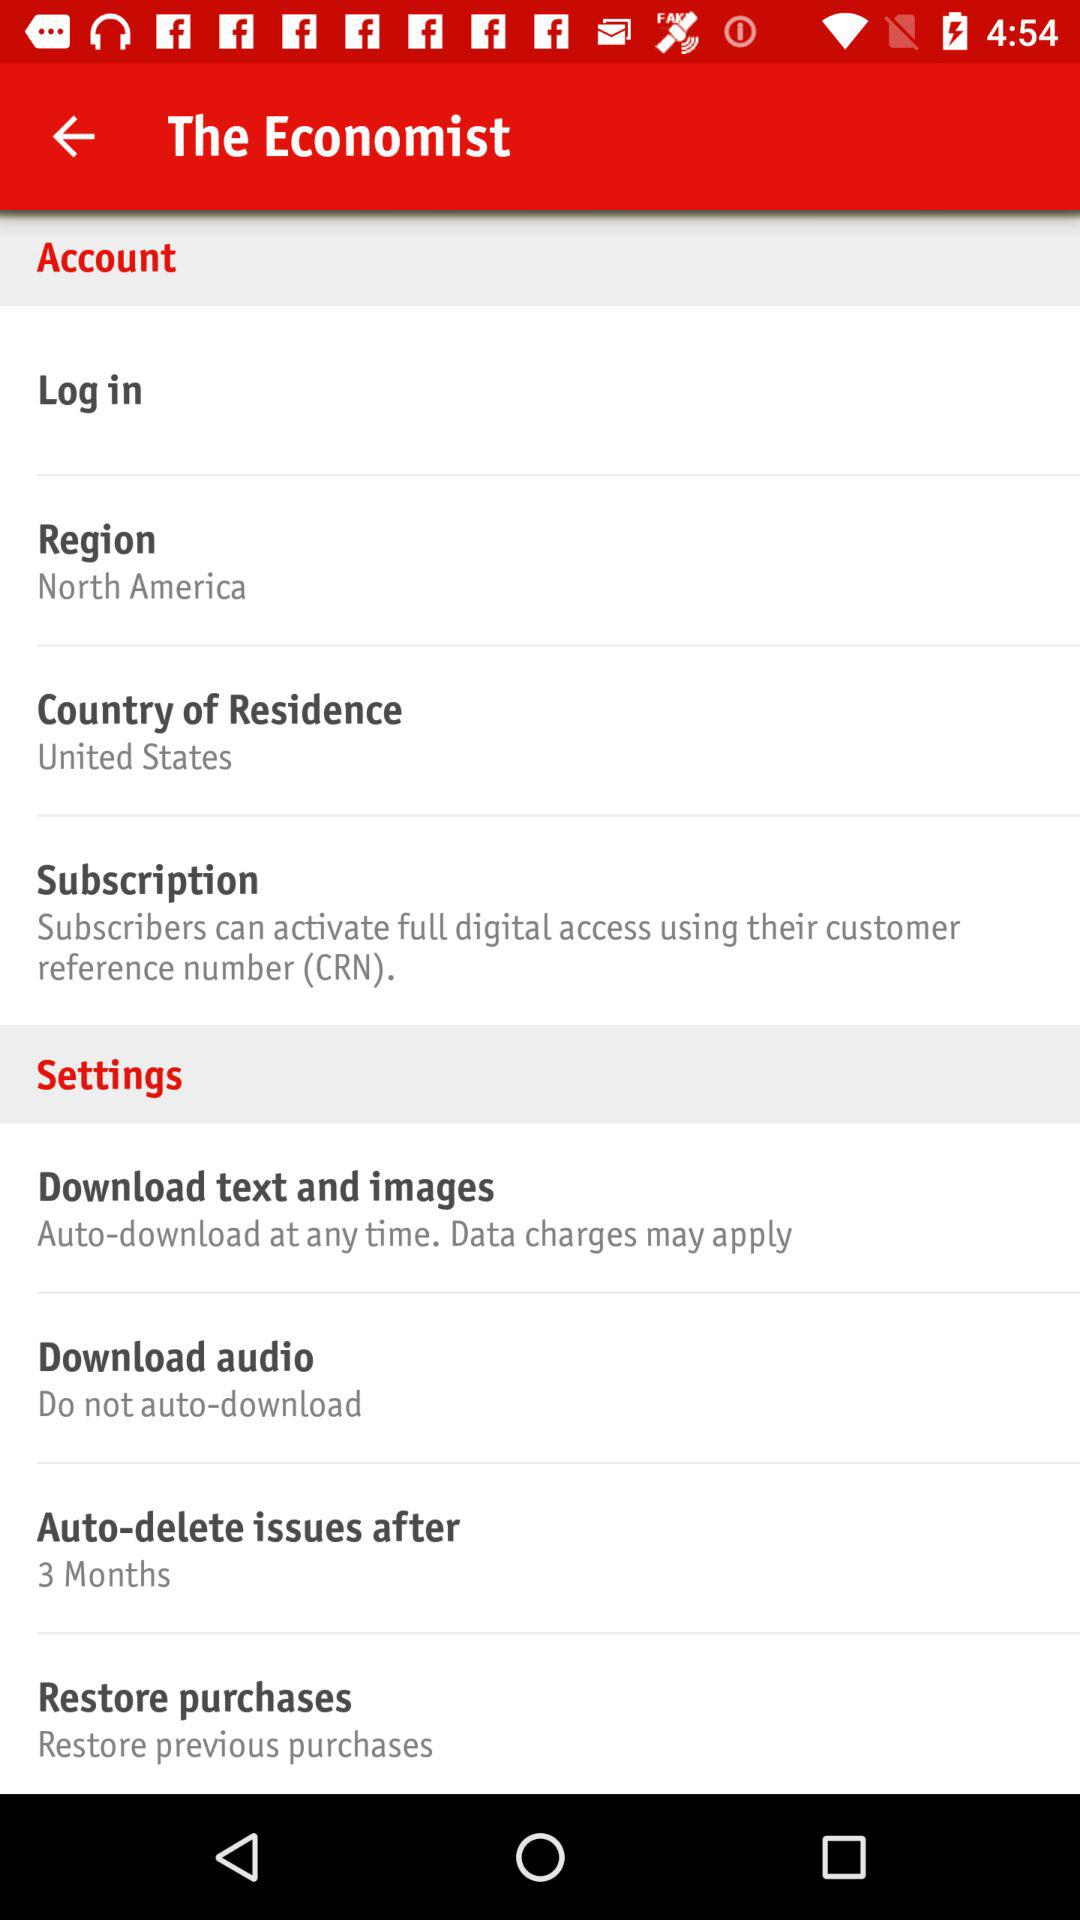Which "Region" is selected? The selected "Region" is North America. 